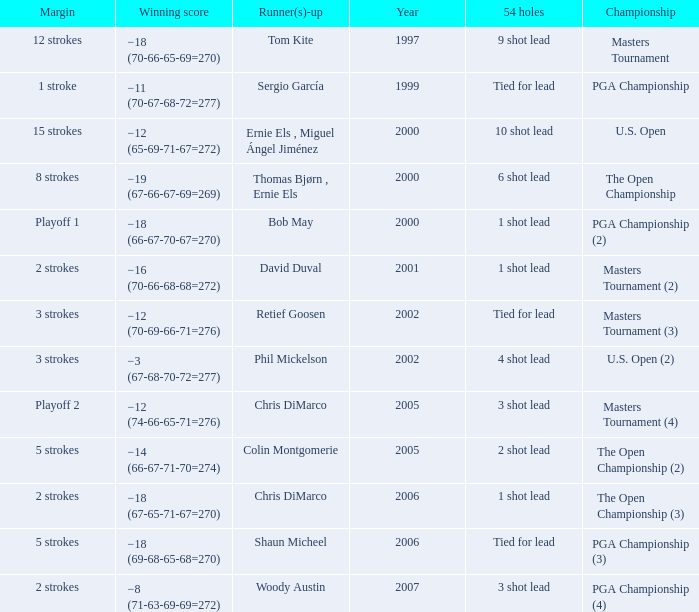 what's the 54 holes where winning score is −19 (67-66-67-69=269) 6 shot lead. 